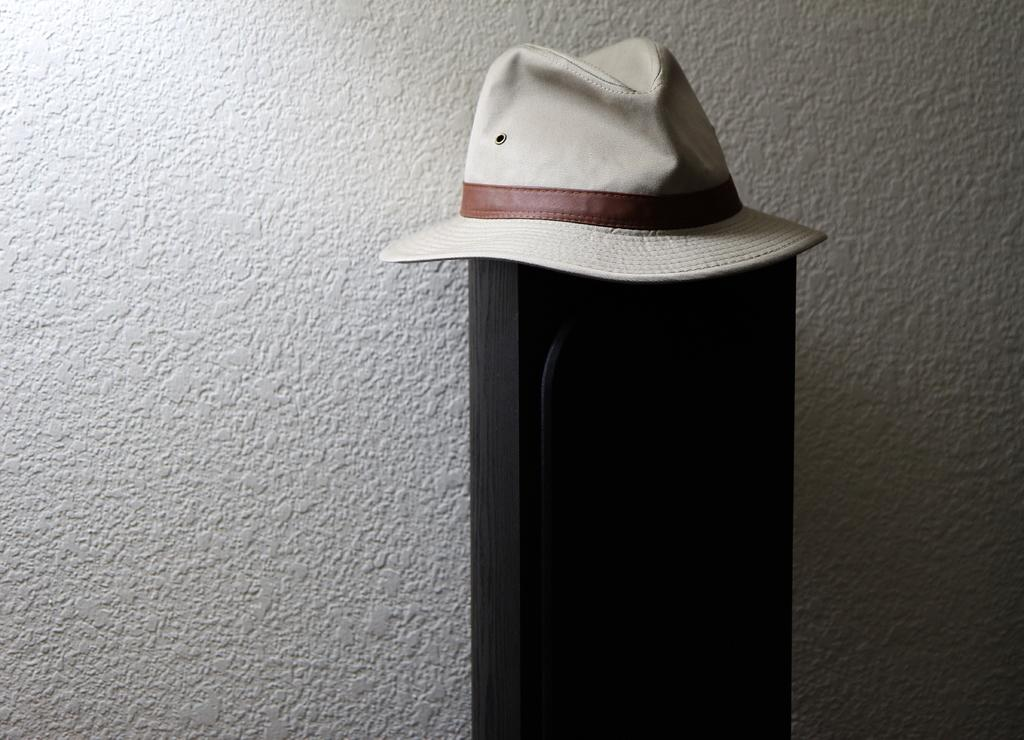What type of table is in the image? There is a wooden table in the image. What object is placed on the table? There is a cap placed on the table. Where is the map located in the image? There is no map present in the image. 